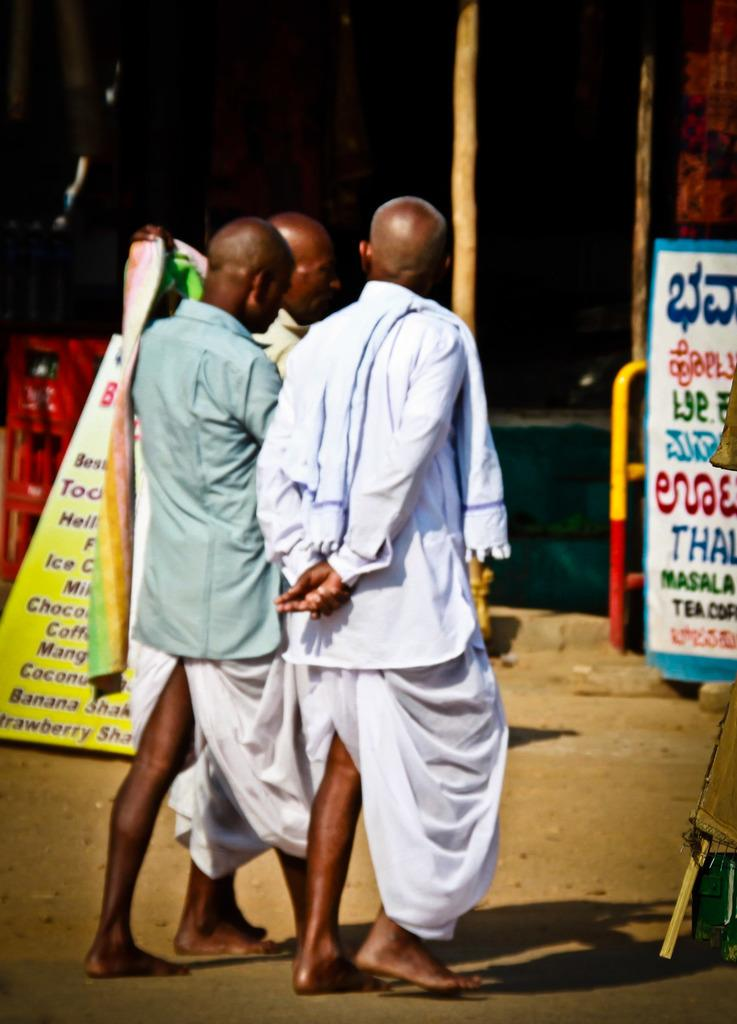Who or what can be seen in the image? There are people in the image. What else is present in the image besides the people? There are banners in the image. Can you describe the banners in the image? The banners have writing on them. What can be observed about the overall appearance of the image? The background of the image is dark. How many kittens are playing with the force in the image? There are no kittens or any reference to a force in the image. 